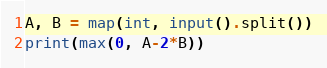<code> <loc_0><loc_0><loc_500><loc_500><_Python_>A, B = map(int, input().split())
print(max(0, A-2*B))</code> 